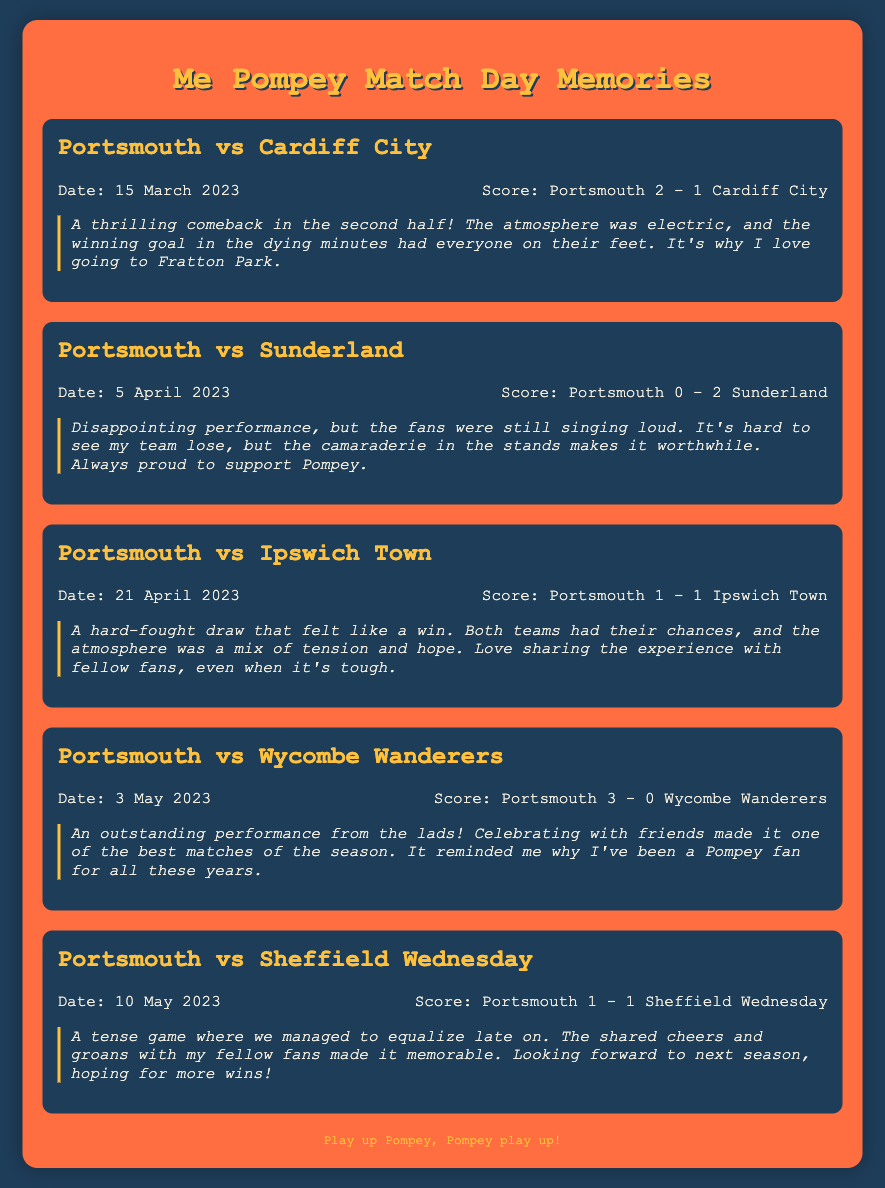what was the score of Portsmouth vs Cardiff City? The score is found in the match summary for Portsmouth vs Cardiff City dated 15 March 2023.
Answer: Portsmouth 2 - 1 Cardiff City when did Portsmouth play against Sunderland? The date is specified in the match information for Portsmouth vs Sunderland.
Answer: 5 April 2023 how many matches ended in a draw? The total number of matches that ended in a draw is determined by checking the results for matches with the same score for both teams.
Answer: 2 what was the reflection for the match against Wycombe Wanderers? The reflection provides personal sentiments about the match against Wycombe Wanderers and is found in the corresponding match section.
Answer: An outstanding performance from the lads! Celebrating with friends made it one of the best matches of the season. It reminded me why I've been a Pompey fan for all these years which opponent did Portsmouth have a comeback against? This information can be derived from the reflection on the match with a thrilling comeback mentioned in the document.
Answer: Cardiff City 